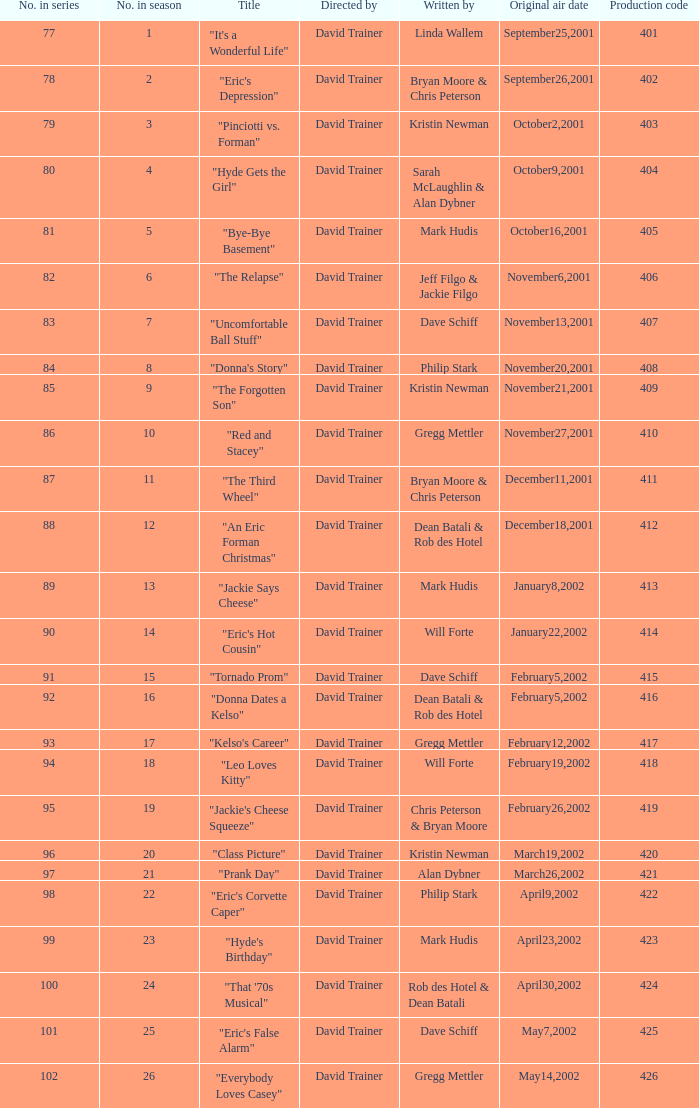In the season, what quantity of production codes added up to 8? 1.0. 